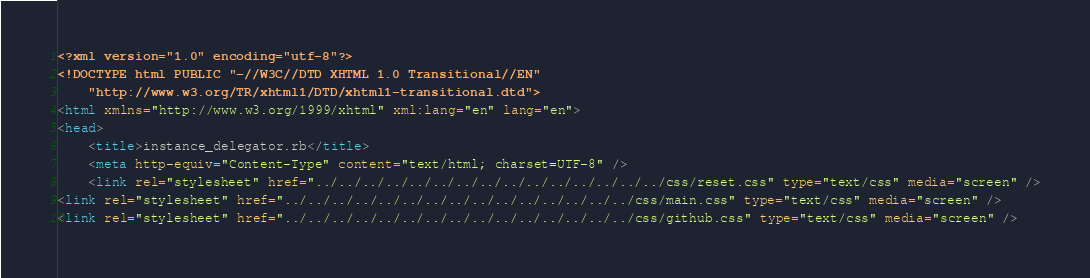<code> <loc_0><loc_0><loc_500><loc_500><_HTML_><?xml version="1.0" encoding="utf-8"?>
<!DOCTYPE html PUBLIC "-//W3C//DTD XHTML 1.0 Transitional//EN"
    "http://www.w3.org/TR/xhtml1/DTD/xhtml1-transitional.dtd">
<html xmlns="http://www.w3.org/1999/xhtml" xml:lang="en" lang="en">
<head>
    <title>instance_delegator.rb</title>
    <meta http-equiv="Content-Type" content="text/html; charset=UTF-8" />
    <link rel="stylesheet" href="../../../../../../../../../../../../../../../css/reset.css" type="text/css" media="screen" />
<link rel="stylesheet" href="../../../../../../../../../../../../../../../css/main.css" type="text/css" media="screen" />
<link rel="stylesheet" href="../../../../../../../../../../../../../../../css/github.css" type="text/css" media="screen" /></code> 